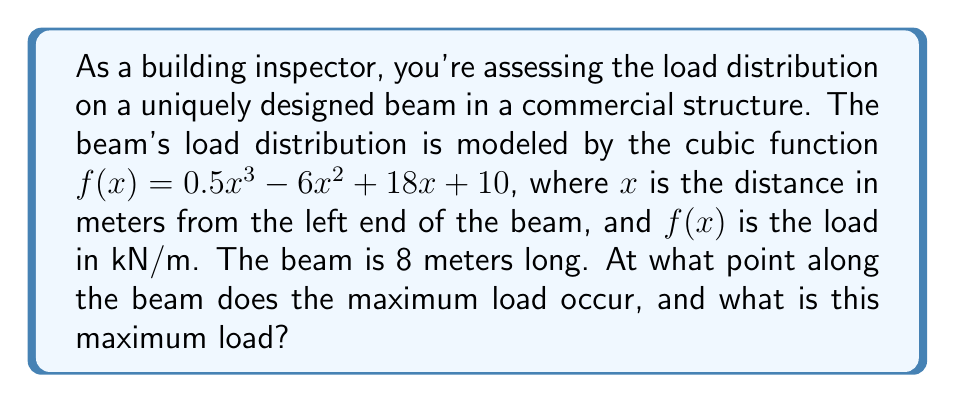Give your solution to this math problem. To solve this problem, we need to follow these steps:

1) The maximum load will occur at the point where the derivative of the function is zero. So, we need to find $f'(x)$ and set it equal to zero.

2) $f'(x) = 1.5x^2 - 12x + 18$

3) Set $f'(x) = 0$:
   $1.5x^2 - 12x + 18 = 0$

4) This is a quadratic equation. We can solve it using the quadratic formula:
   $x = \frac{-b \pm \sqrt{b^2 - 4ac}}{2a}$

   Where $a = 1.5$, $b = -12$, and $c = 18$

5) Plugging in these values:
   $x = \frac{12 \pm \sqrt{144 - 108}}{3} = \frac{12 \pm \sqrt{36}}{3} = \frac{12 \pm 6}{3}$

6) This gives us two solutions:
   $x_1 = \frac{12 + 6}{3} = 6$ and $x_2 = \frac{12 - 6}{3} = 2$

7) Since the beam is 8 meters long, both of these points are on the beam. To determine which one is the maximum, we need to check the second derivative:

   $f''(x) = 3x - 12$

8) At $x = 2$: $f''(2) = 3(2) - 12 = -6 < 0$, indicating a local maximum
   At $x = 6$: $f''(6) = 3(6) - 12 = 6 > 0$, indicating a local minimum

9) Therefore, the maximum load occurs at $x = 2$ meters from the left end of the beam.

10) To find the maximum load, we plug $x = 2$ into our original function:

    $f(2) = 0.5(2)^3 - 6(2)^2 + 18(2) + 10 = 4 - 24 + 36 + 10 = 26$

Thus, the maximum load is 26 kN/m.
Answer: The maximum load occurs at 2 meters from the left end of the beam, and the maximum load is 26 kN/m. 